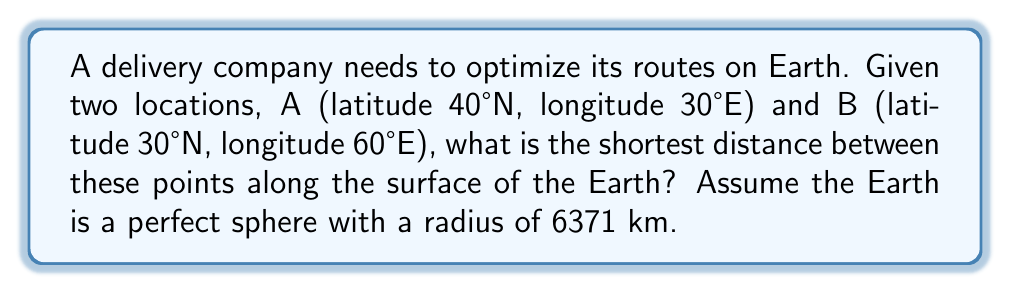Can you solve this math problem? To find the shortest path between two points on a spherical surface, we need to calculate the great circle distance. This can be done using the haversine formula:

1. Convert the latitudes and longitudes to radians:
   $\phi_1 = 40° \cdot \frac{\pi}{180} = 0.6981$ rad
   $\lambda_1 = 30° \cdot \frac{\pi}{180} = 0.5236$ rad
   $\phi_2 = 30° \cdot \frac{\pi}{180} = 0.5236$ rad
   $\lambda_2 = 60° \cdot \frac{\pi}{180} = 1.0472$ rad

2. Calculate the difference in longitude:
   $\Delta\lambda = \lambda_2 - \lambda_1 = 1.0472 - 0.5236 = 0.5236$ rad

3. Apply the haversine formula:
   $$a = \sin^2(\frac{\Delta\phi}{2}) + \cos(\phi_1) \cdot \cos(\phi_2) \cdot \sin^2(\frac{\Delta\lambda}{2})$$
   $$a = \sin^2(\frac{0.5236 - 0.6981}{2}) + \cos(0.6981) \cdot \cos(0.5236) \cdot \sin^2(\frac{0.5236}{2})$$
   $$a = 0.0841$$

4. Calculate the central angle:
   $$c = 2 \cdot \arctan2(\sqrt{a}, \sqrt{1-a})$$
   $$c = 2 \cdot \arctan2(\sqrt{0.0841}, \sqrt{1-0.0841}) = 0.5904$$ rad

5. Calculate the distance:
   $$d = R \cdot c$$
   $$d = 6371 \cdot 0.5904 = 3761.44$$ km

Therefore, the shortest distance between points A and B along the Earth's surface is approximately 3761.44 km.
Answer: 3761.44 km 